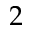Convert formula to latex. <formula><loc_0><loc_0><loc_500><loc_500>2</formula> 